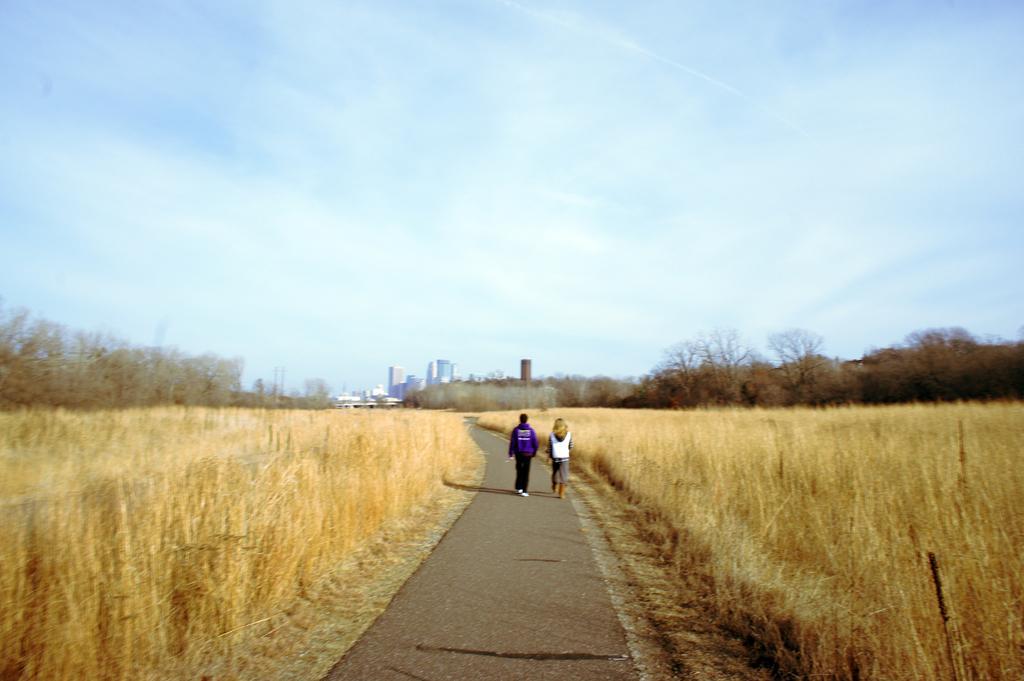In one or two sentences, can you explain what this image depicts? On the right side of the picture there are trees and fields. In the center of the picture there are people walking down the road. On the left the there are and fields. In the background there are trees and buildings. Sky is bit cloudy and it is sunny. 